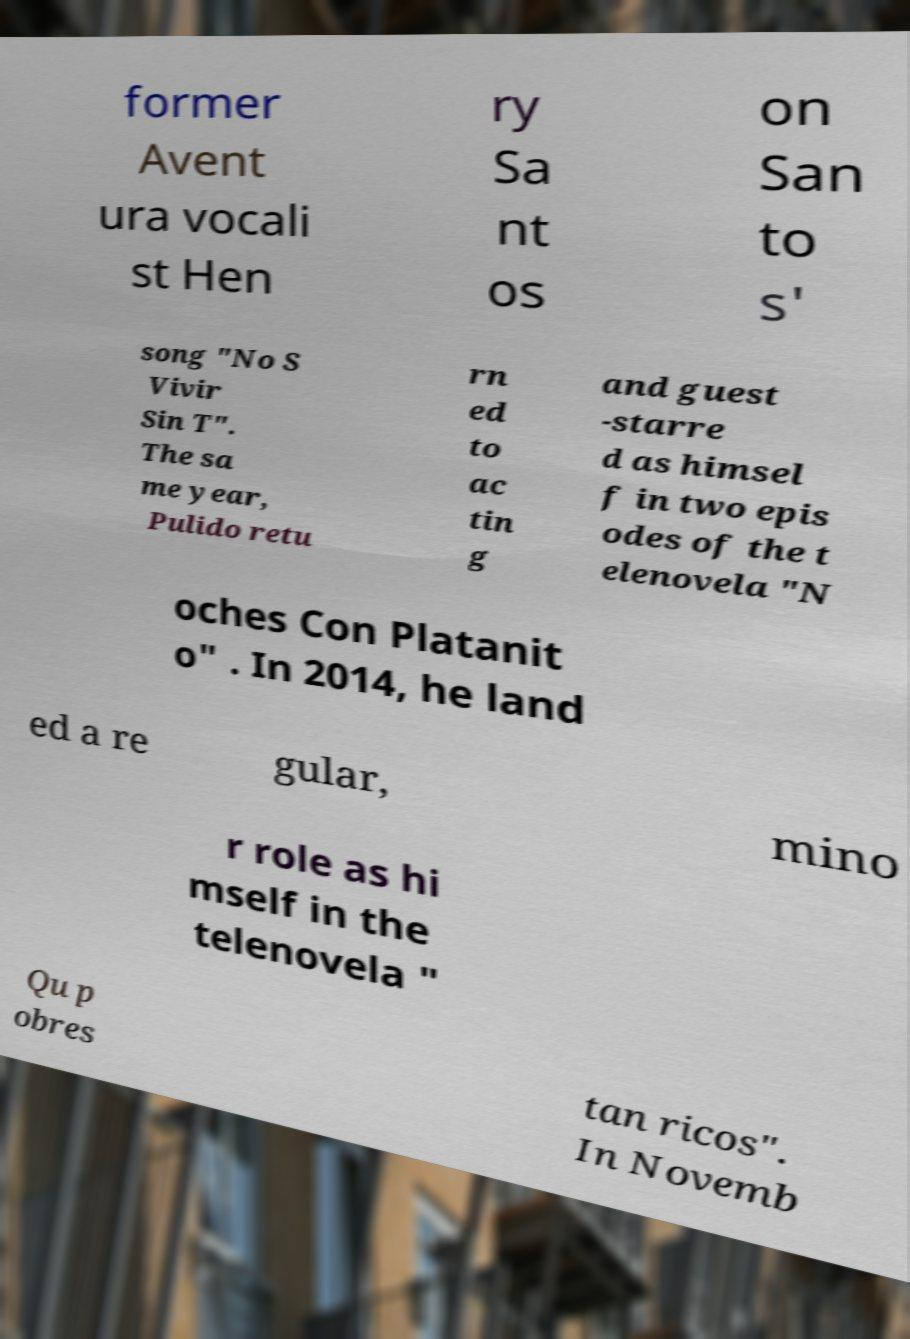What messages or text are displayed in this image? I need them in a readable, typed format. former Avent ura vocali st Hen ry Sa nt os on San to s' song "No S Vivir Sin T". The sa me year, Pulido retu rn ed to ac tin g and guest -starre d as himsel f in two epis odes of the t elenovela "N oches Con Platanit o" . In 2014, he land ed a re gular, mino r role as hi mself in the telenovela " Qu p obres tan ricos". In Novemb 